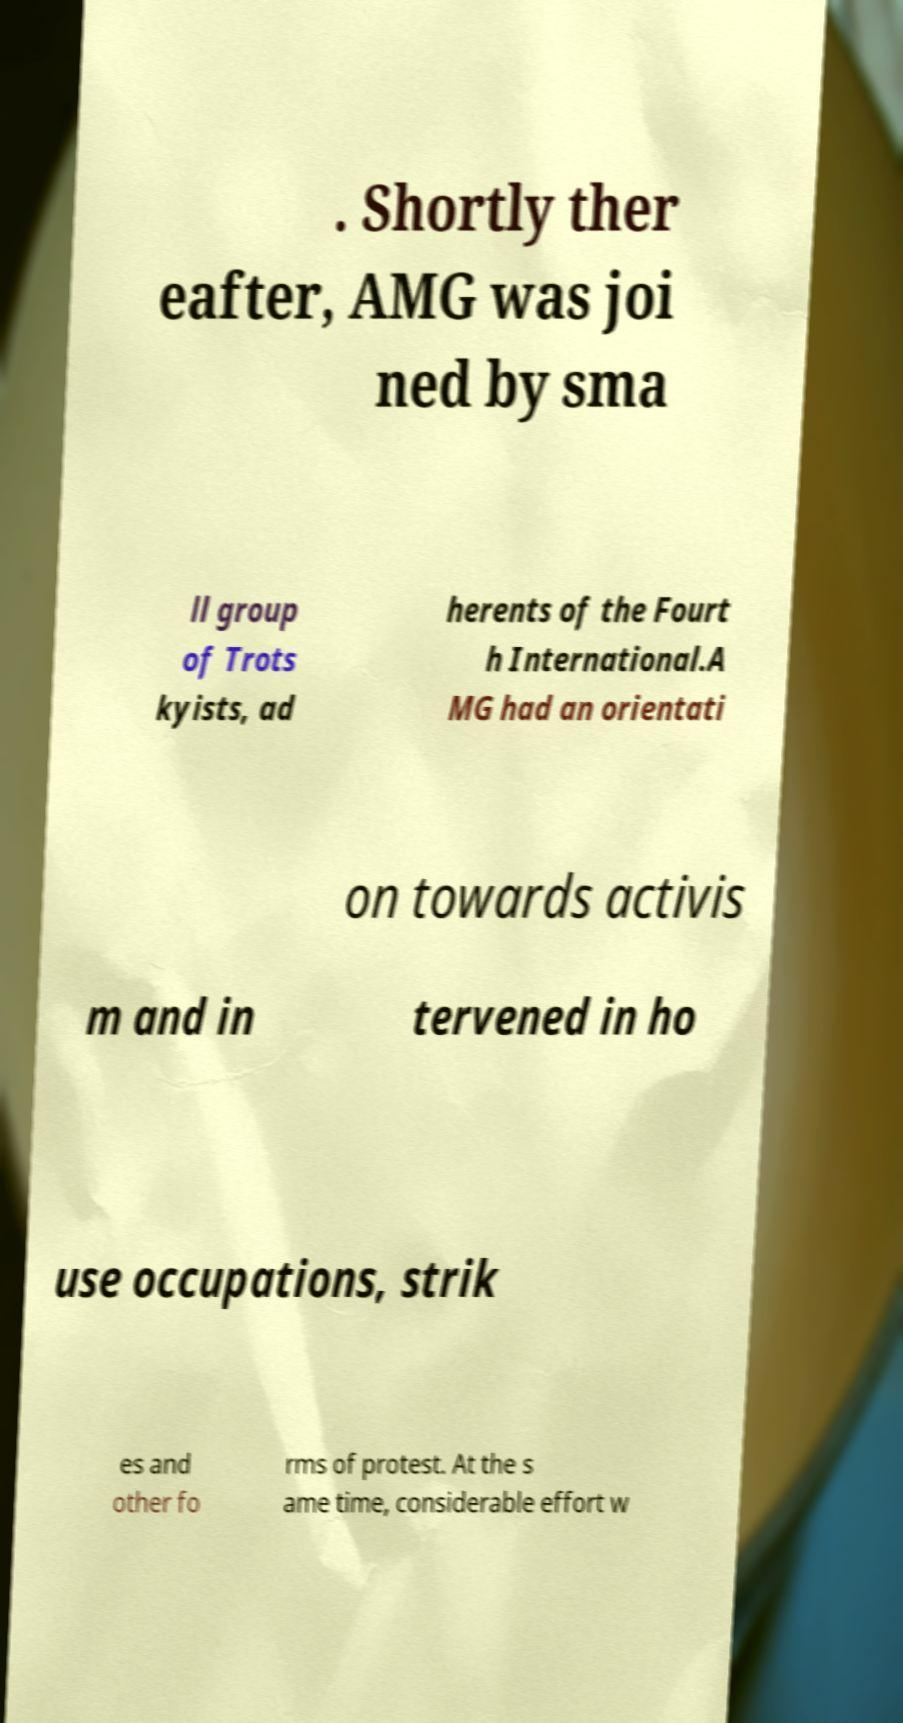There's text embedded in this image that I need extracted. Can you transcribe it verbatim? . Shortly ther eafter, AMG was joi ned by sma ll group of Trots kyists, ad herents of the Fourt h International.A MG had an orientati on towards activis m and in tervened in ho use occupations, strik es and other fo rms of protest. At the s ame time, considerable effort w 